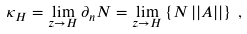<formula> <loc_0><loc_0><loc_500><loc_500>\kappa _ { H } = \lim _ { z \to H } \partial _ { n } N = \lim _ { z \to H } \left \{ N \, | | A | | \right \} \, ,</formula> 